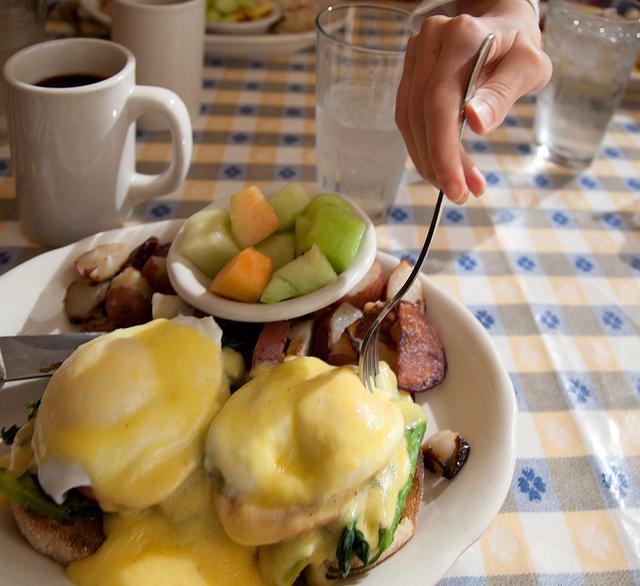What is in the small plate?
Answer the question by selecting the correct answer among the 4 following choices and explain your choice with a short sentence. The answer should be formatted with the following format: `Answer: choice
Rationale: rationale.`
Options: Chicken bone, cantaloupe, apple pie, cherry. Answer: cantaloupe.
Rationale: The plate at the top has orangish and light green melons in it. 